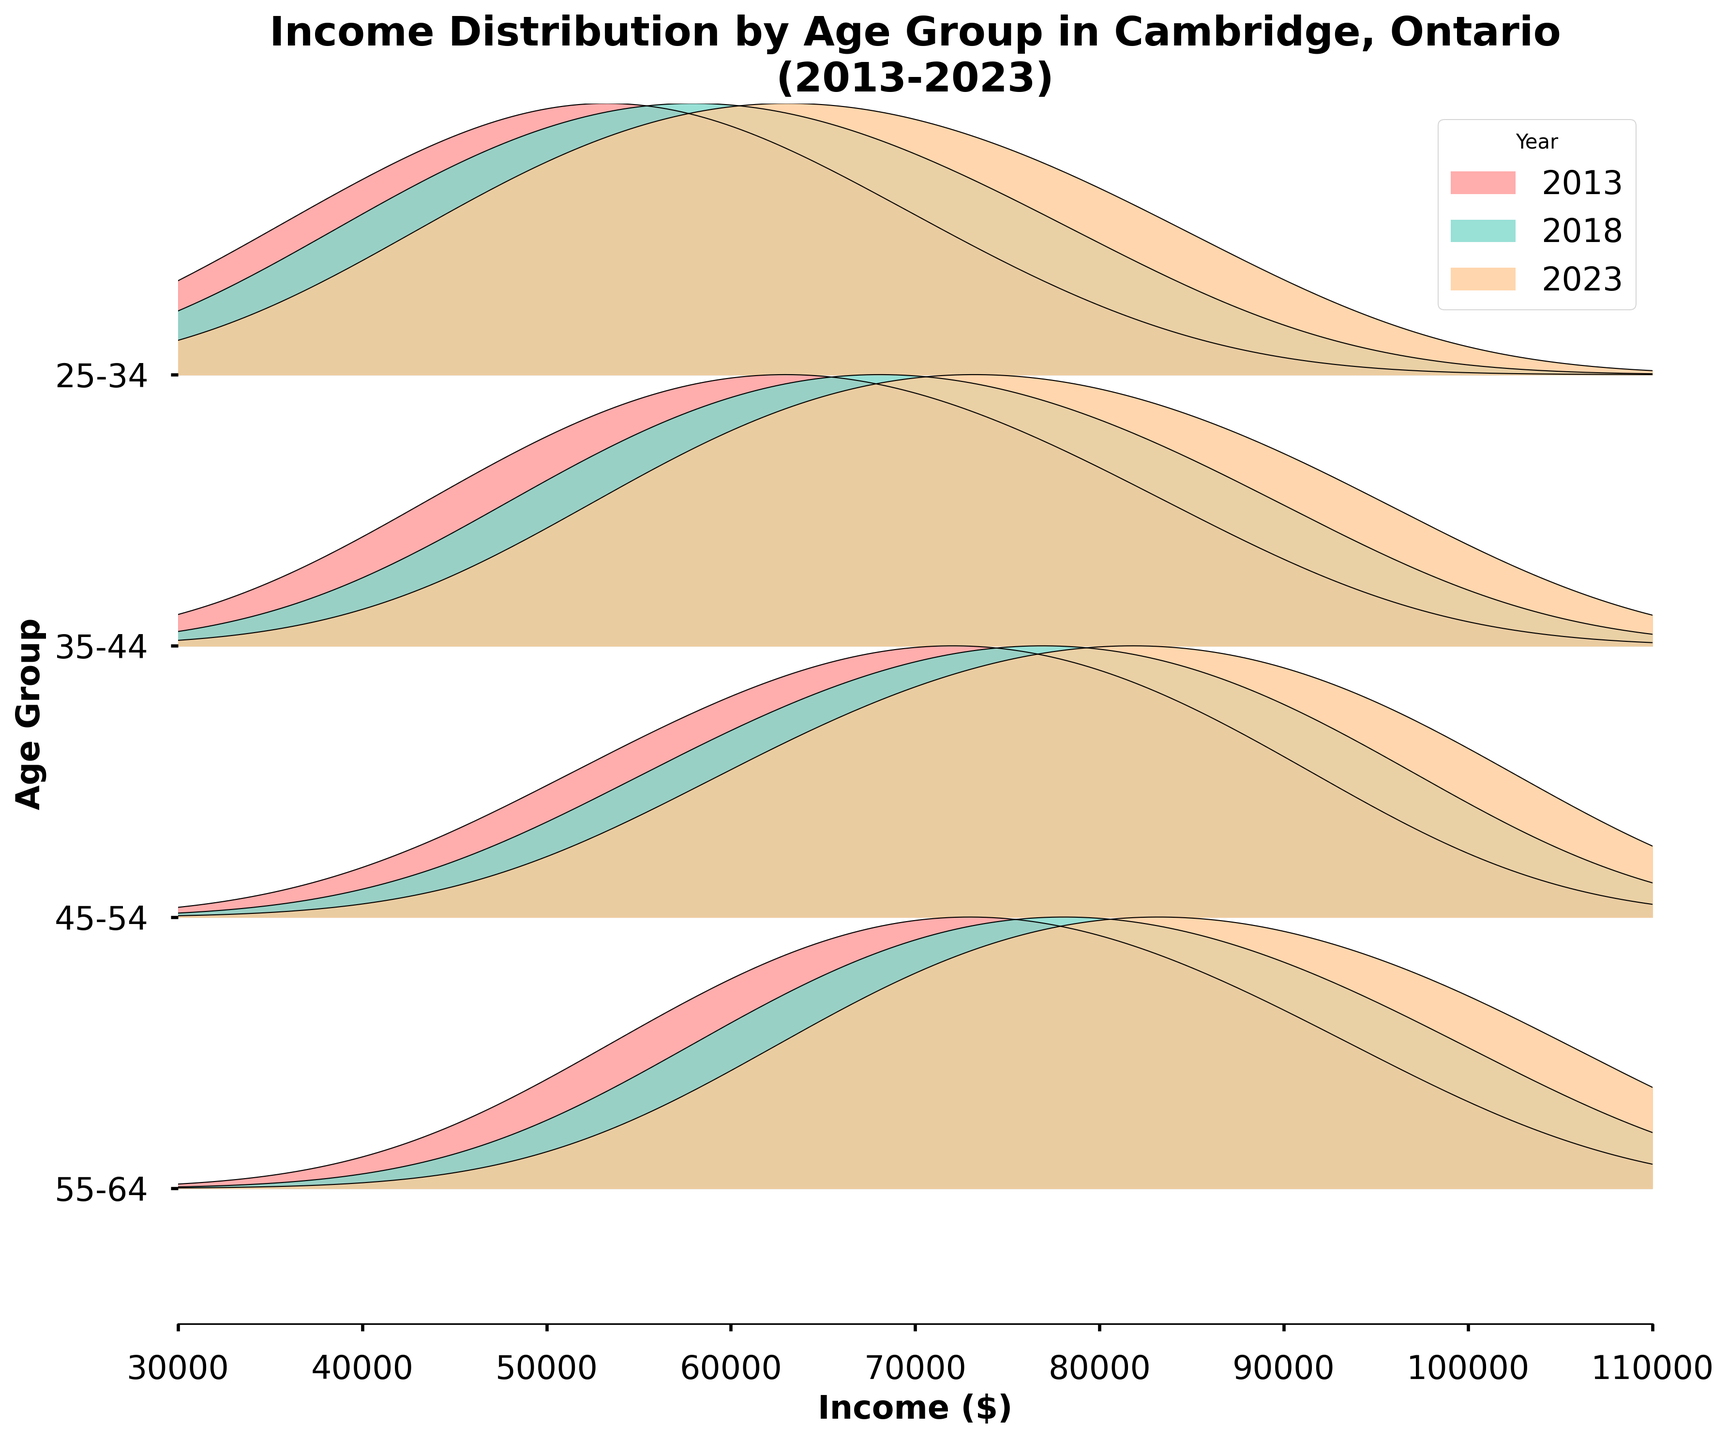What is the title of the plot? The title is typically displayed at the top of the figure. In this case, the title as stated in the code is "Income Distribution by Age Group in Cambridge, Ontario\n(2013-2023)".
Answer: Income Distribution by Age Group in Cambridge, Ontario (2013-2023) How many age groups are represented in the plot? The code indicates that the data is split into four different age groups: 25-34, 35-44, 45-54, and 55-64. These are shown on the y-axis.
Answer: 4 What is the range of income displayed on the x-axis? The code and data specify that the income ranges from 30,000 to 110,000. This is represented on the x-axis of the plot.
Answer: 30,000 to 110,000 Which age group showed the highest peak density in 2023? By looking at the ridgeline plot, locate the curves for each age group in 2023 and compare the peak densities. The age group with the highest peak density in this case would be the 45-54 age group, as it has the highest curve.
Answer: 45-54 How did the income densities for the 25-34 age group change from 2013 to 2023? By comparing the ridgeline plots across different years for the 25-34 age group, you can observe how the peaks and distributions have shifted. For 25-34, the peak densities have increased and shifted higher in income in 2023 compared to 2013.
Answer: Increased and shifted higher What is the general trend in income distribution for the 55-64 age group from 2013 to 2023? By analyzing the ridgeline plots for the 55-64 age group across the years, you can observe the shifts in the income distribution curves. It generally shows an increase in income and density over time.
Answer: Increase in income and density Which year shows the widest spread of income distribution for the 35-44 age group? By examining the width of the ridgeline plots for the 35-44 age group across different years, 2023 seems to have the widest spread as the curve flattens out towards higher incomes.
Answer: 2023 How does the income distribution for the 45-54 age group in 2018 compare to that in 2013? By comparing the ridgeline plots for the 45-54 age group in these two years, the 2018 distribution shifts slightly to higher incomes and higher densities than in 2013.
Answer: Shifted to higher incomes and densities Which age group had the highest income peak density in 2018? By examining the ridgeline plots for 2018, the highest income peak density is found in the 45-54 age group.
Answer: 45-54 